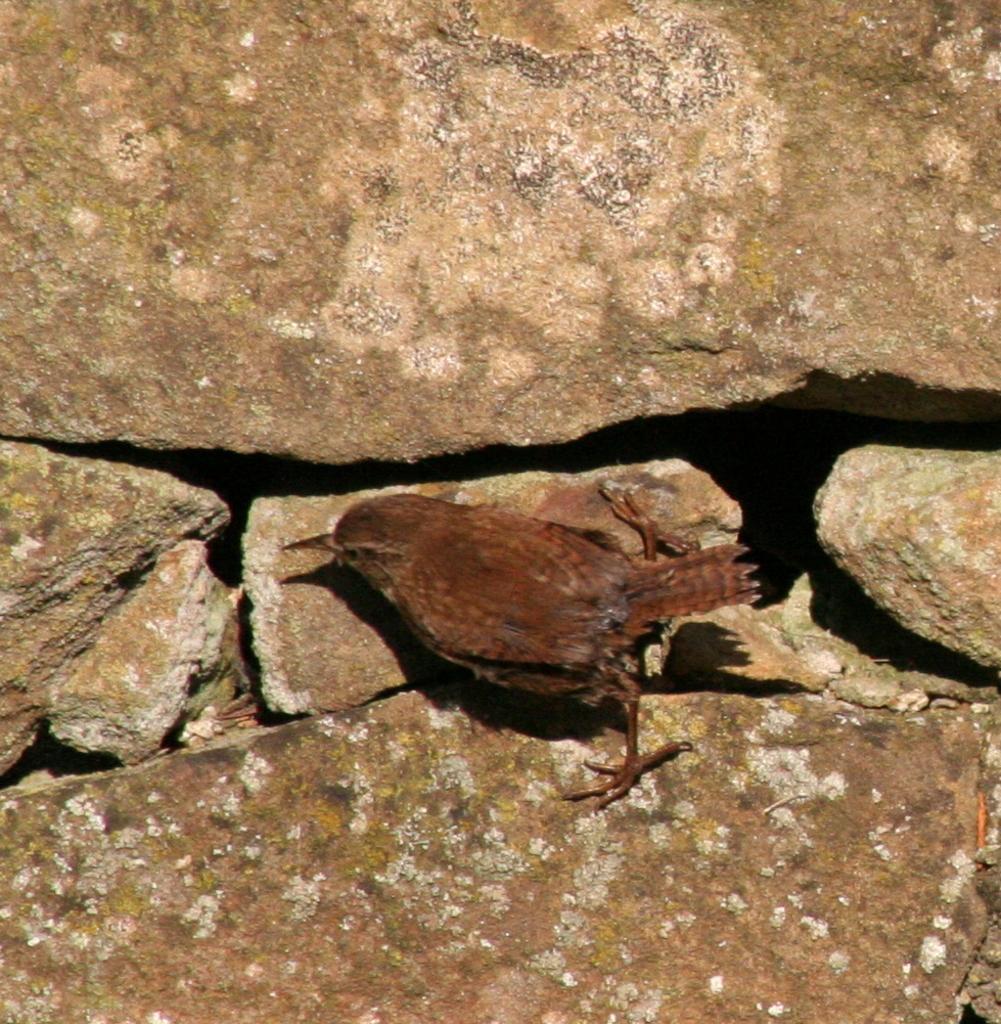Describe this image in one or two sentences. In this image there is a bird on the rock. 